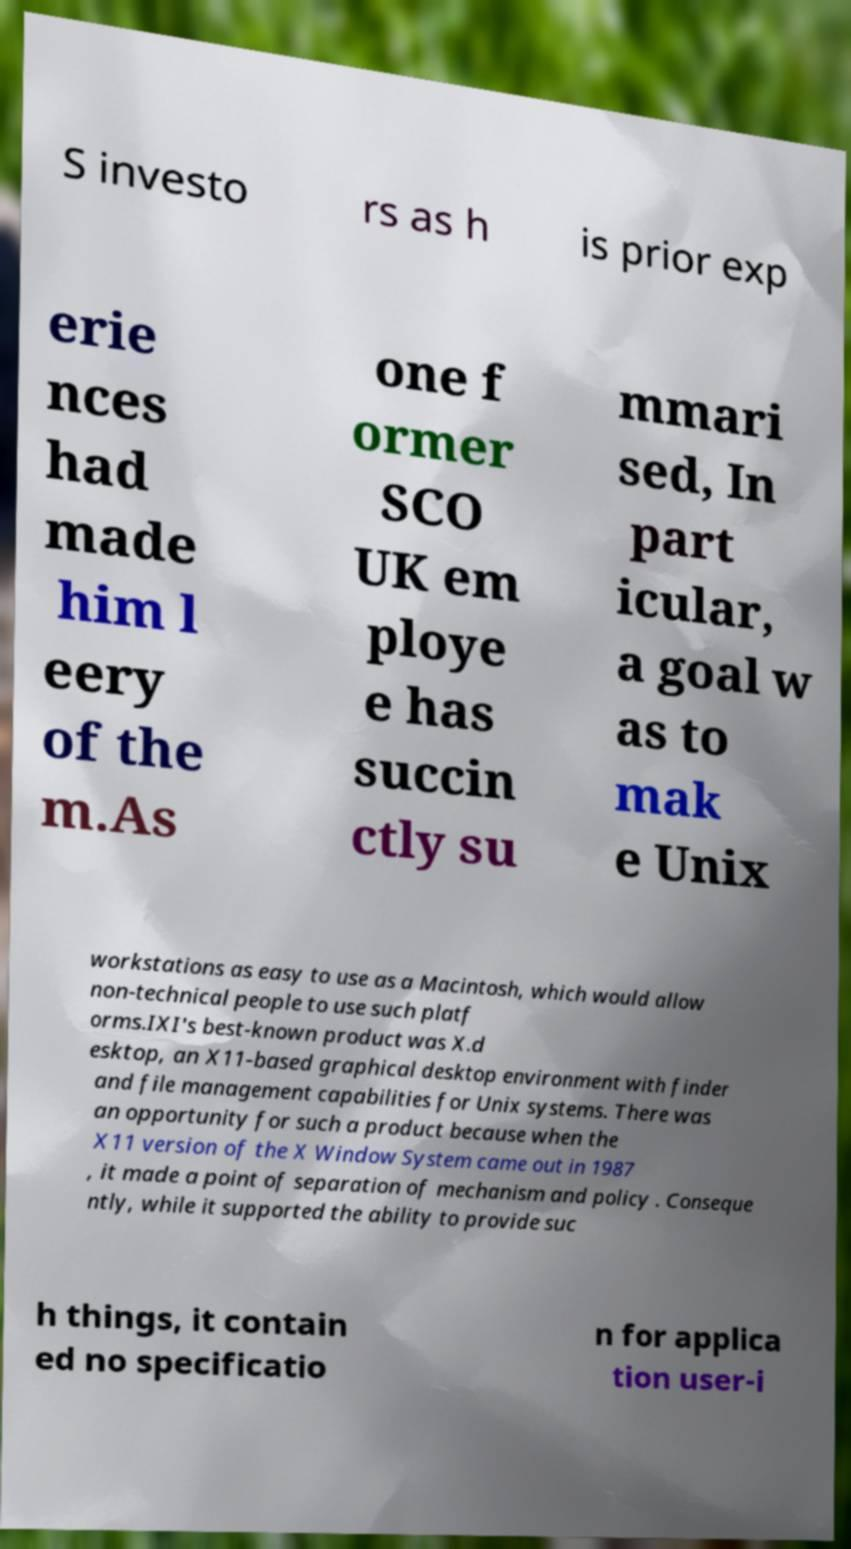Can you read and provide the text displayed in the image?This photo seems to have some interesting text. Can you extract and type it out for me? S investo rs as h is prior exp erie nces had made him l eery of the m.As one f ormer SCO UK em ploye e has succin ctly su mmari sed, In part icular, a goal w as to mak e Unix workstations as easy to use as a Macintosh, which would allow non-technical people to use such platf orms.IXI's best-known product was X.d esktop, an X11-based graphical desktop environment with finder and file management capabilities for Unix systems. There was an opportunity for such a product because when the X11 version of the X Window System came out in 1987 , it made a point of separation of mechanism and policy . Conseque ntly, while it supported the ability to provide suc h things, it contain ed no specificatio n for applica tion user-i 